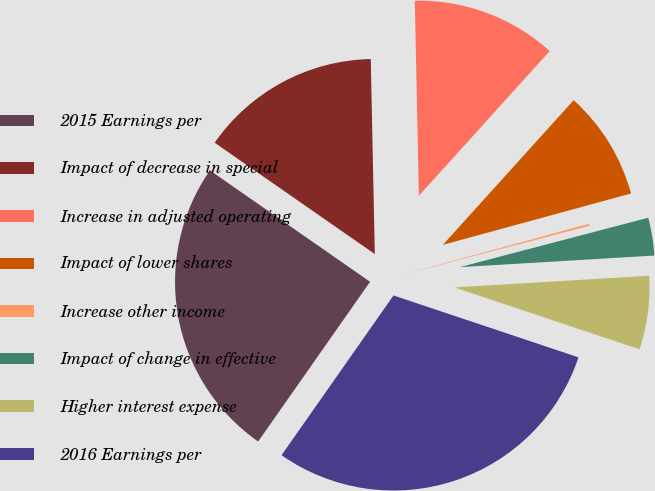<chart> <loc_0><loc_0><loc_500><loc_500><pie_chart><fcel>2015 Earnings per<fcel>Impact of decrease in special<fcel>Increase in adjusted operating<fcel>Impact of lower shares<fcel>Increase other income<fcel>Impact of change in effective<fcel>Higher interest expense<fcel>2016 Earnings per<nl><fcel>24.94%<fcel>15.0%<fcel>12.03%<fcel>9.06%<fcel>0.16%<fcel>3.13%<fcel>6.09%<fcel>29.59%<nl></chart> 